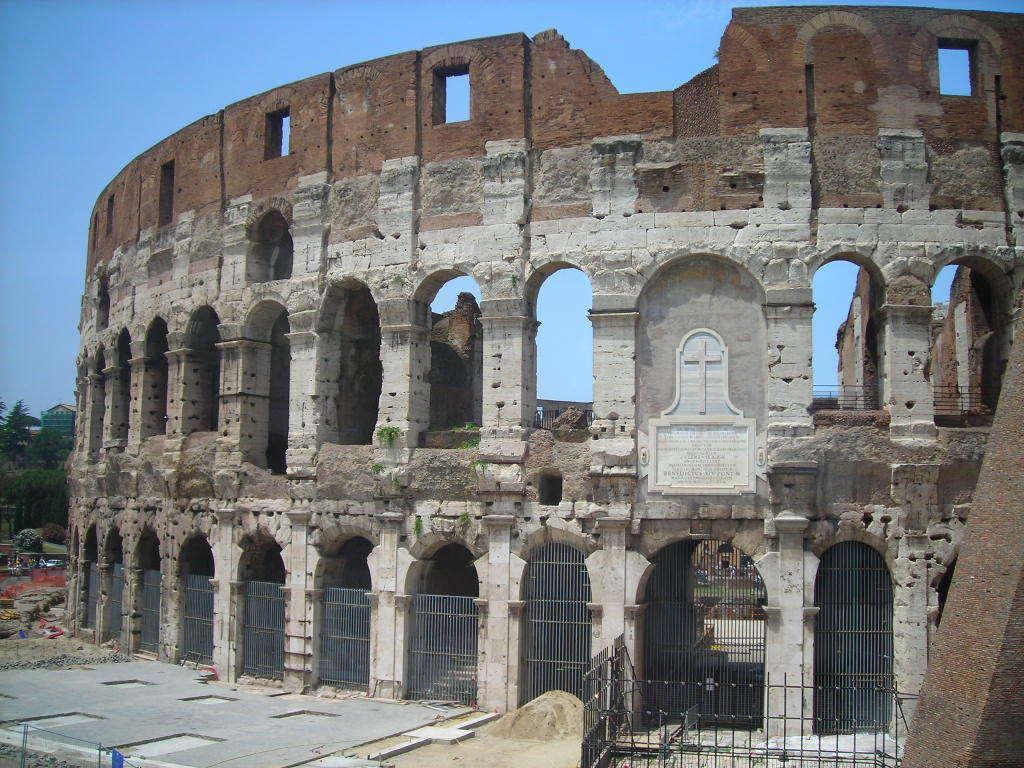How would you summarize this image in a sentence or two? In the center of the image there is a colosseum. On the left there are trees. At the top there is sky. 